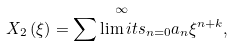Convert formula to latex. <formula><loc_0><loc_0><loc_500><loc_500>X _ { 2 } \left ( \xi \right ) = \overset { \infty } { \sum \lim i t s _ { n = 0 } } a _ { n } \xi ^ { n + k } ,</formula> 